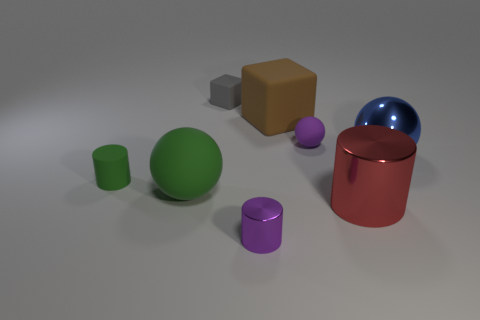Subtract all small purple shiny cylinders. How many cylinders are left? 2 Subtract all gray blocks. How many yellow spheres are left? 0 Subtract all brown blocks. How many blocks are left? 1 Subtract all cylinders. How many objects are left? 5 Add 4 big brown blocks. How many big brown blocks are left? 5 Add 7 large brown cubes. How many large brown cubes exist? 8 Add 2 tiny purple objects. How many objects exist? 10 Subtract 1 green cylinders. How many objects are left? 7 Subtract 3 cylinders. How many cylinders are left? 0 Subtract all green blocks. Subtract all blue cylinders. How many blocks are left? 2 